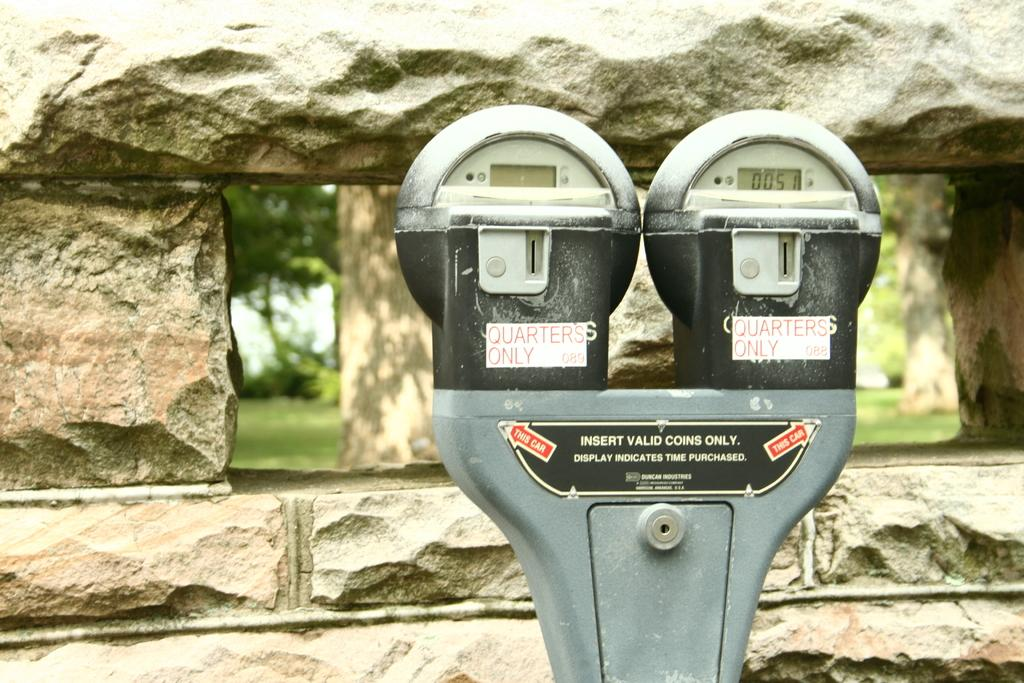<image>
Offer a succinct explanation of the picture presented. Two parking meters that have a sticker saying Quarters Only. 